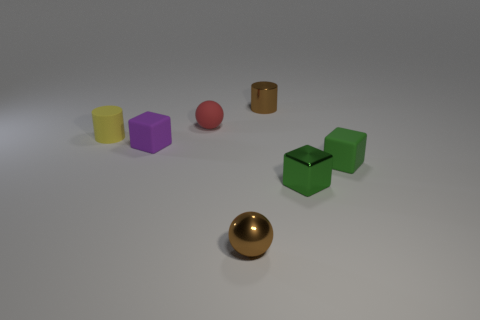Add 2 green metal objects. How many objects exist? 9 Subtract all blocks. How many objects are left? 4 Add 3 tiny blocks. How many tiny blocks are left? 6 Add 7 red balls. How many red balls exist? 8 Subtract 0 cyan blocks. How many objects are left? 7 Subtract all green matte blocks. Subtract all green matte objects. How many objects are left? 5 